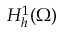<formula> <loc_0><loc_0><loc_500><loc_500>H _ { h } ^ { 1 } ( \Omega )</formula> 